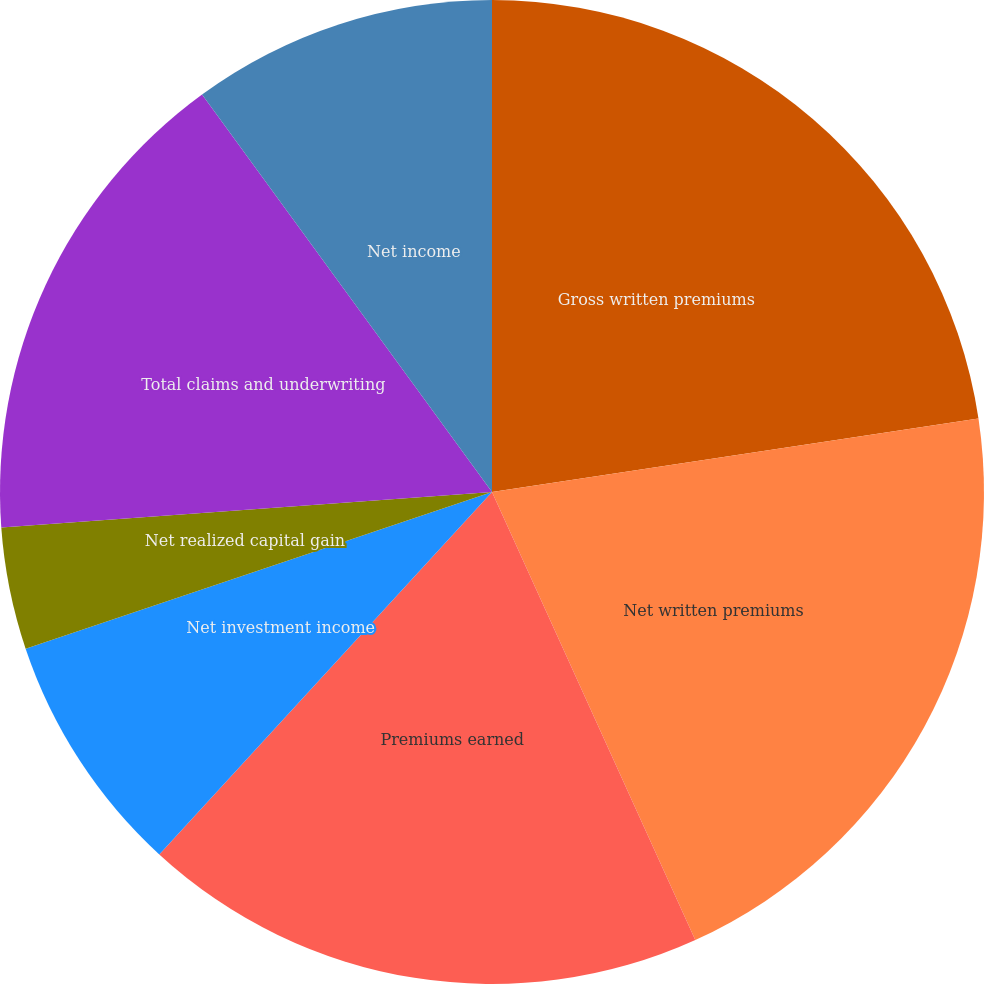Convert chart. <chart><loc_0><loc_0><loc_500><loc_500><pie_chart><fcel>Gross written premiums<fcel>Net written premiums<fcel>Premiums earned<fcel>Net investment income<fcel>Net realized capital gain<fcel>Total claims and underwriting<fcel>Net income<fcel>Net income per common share -<nl><fcel>22.61%<fcel>20.61%<fcel>18.6%<fcel>8.02%<fcel>4.01%<fcel>16.12%<fcel>10.03%<fcel>0.0%<nl></chart> 